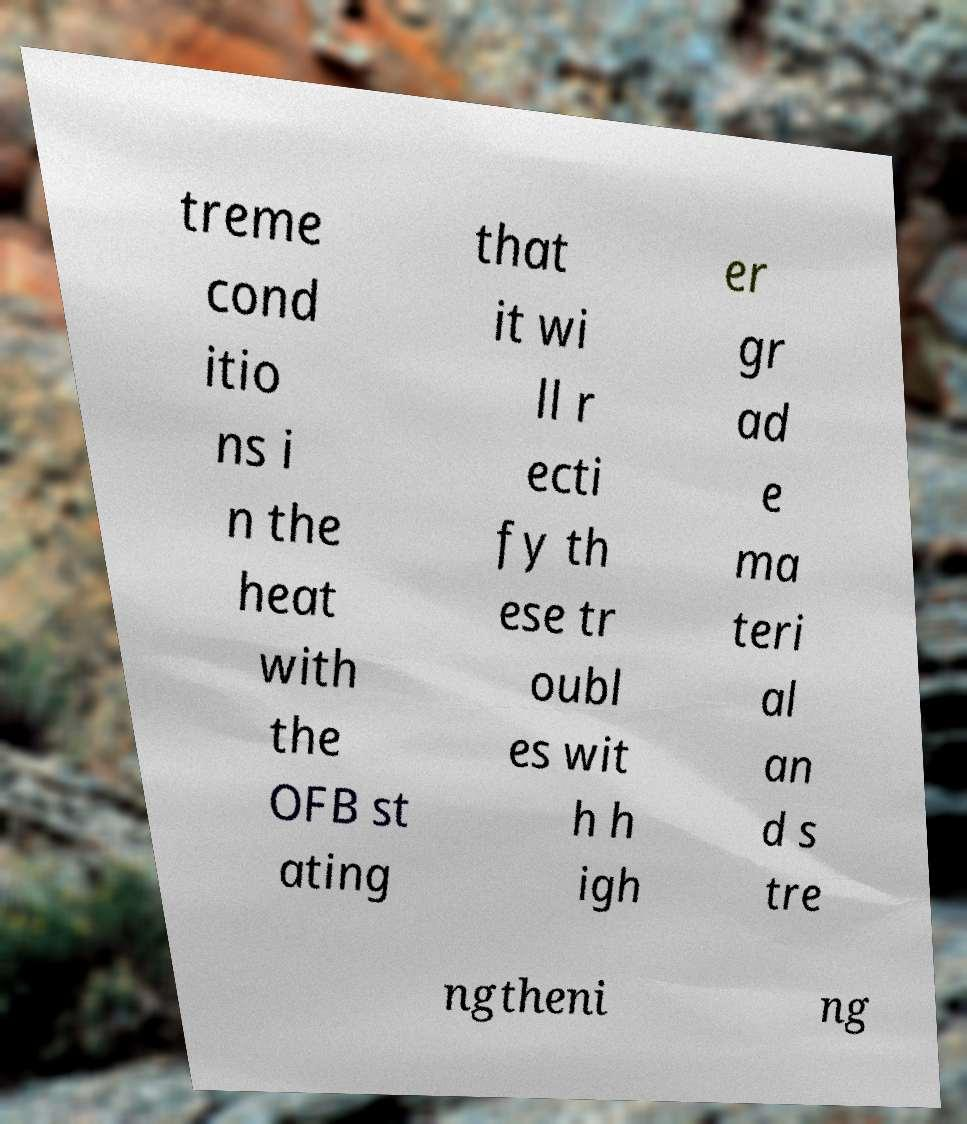Could you assist in decoding the text presented in this image and type it out clearly? treme cond itio ns i n the heat with the OFB st ating that it wi ll r ecti fy th ese tr oubl es wit h h igh er gr ad e ma teri al an d s tre ngtheni ng 